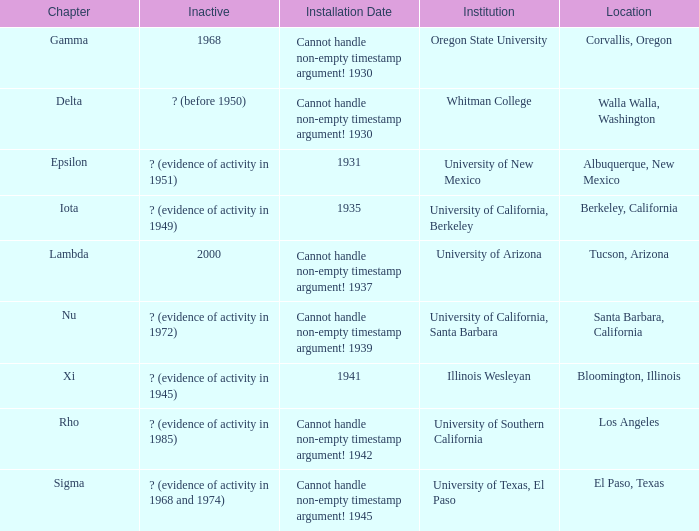What is the installation date for the Delta Chapter? Cannot handle non-empty timestamp argument! 1930. Give me the full table as a dictionary. {'header': ['Chapter', 'Inactive', 'Installation Date', 'Institution', 'Location'], 'rows': [['Gamma', '1968', 'Cannot handle non-empty timestamp argument! 1930', 'Oregon State University', 'Corvallis, Oregon'], ['Delta', '? (before 1950)', 'Cannot handle non-empty timestamp argument! 1930', 'Whitman College', 'Walla Walla, Washington'], ['Epsilon', '? (evidence of activity in 1951)', '1931', 'University of New Mexico', 'Albuquerque, New Mexico'], ['Iota', '? (evidence of activity in 1949)', '1935', 'University of California, Berkeley', 'Berkeley, California'], ['Lambda', '2000', 'Cannot handle non-empty timestamp argument! 1937', 'University of Arizona', 'Tucson, Arizona'], ['Nu', '? (evidence of activity in 1972)', 'Cannot handle non-empty timestamp argument! 1939', 'University of California, Santa Barbara', 'Santa Barbara, California'], ['Xi', '? (evidence of activity in 1945)', '1941', 'Illinois Wesleyan', 'Bloomington, Illinois'], ['Rho', '? (evidence of activity in 1985)', 'Cannot handle non-empty timestamp argument! 1942', 'University of Southern California', 'Los Angeles'], ['Sigma', '? (evidence of activity in 1968 and 1974)', 'Cannot handle non-empty timestamp argument! 1945', 'University of Texas, El Paso', 'El Paso, Texas']]} 